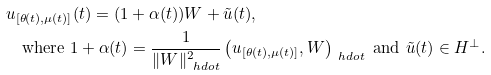<formula> <loc_0><loc_0><loc_500><loc_500>& u _ { [ \theta ( t ) , \mu ( t ) ] } ( t ) = ( 1 + \alpha ( t ) ) W + \tilde { u } ( t ) , \\ & \quad \text {where } 1 + \alpha ( t ) = \frac { 1 } { \| W \| _ { \ h d o t } ^ { 2 } } \left ( u _ { [ \theta ( t ) , \mu ( t ) ] } , W \right ) _ { \ h d o t } \text { and } \tilde { u } ( t ) \in H ^ { \bot } .</formula> 